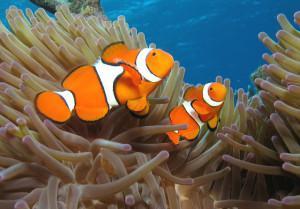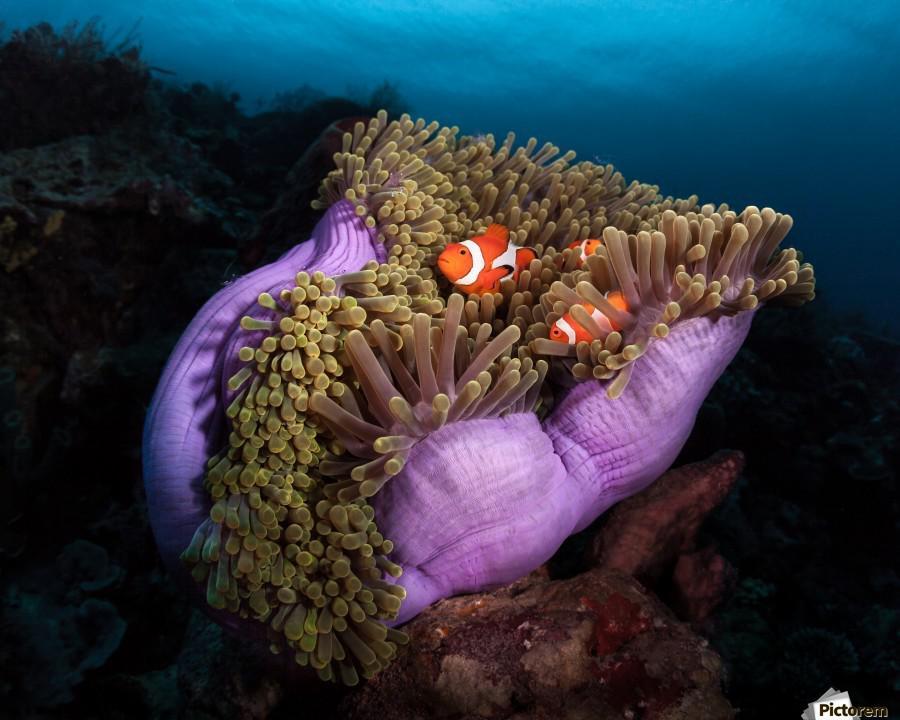The first image is the image on the left, the second image is the image on the right. Assess this claim about the two images: "One image shows two fish in anemone tendrils that emerge from a dark-orangish """"stalk"""".". Correct or not? Answer yes or no. No. The first image is the image on the left, the second image is the image on the right. For the images displayed, is the sentence "There are exactly two clownfish in the right image." factually correct? Answer yes or no. No. 